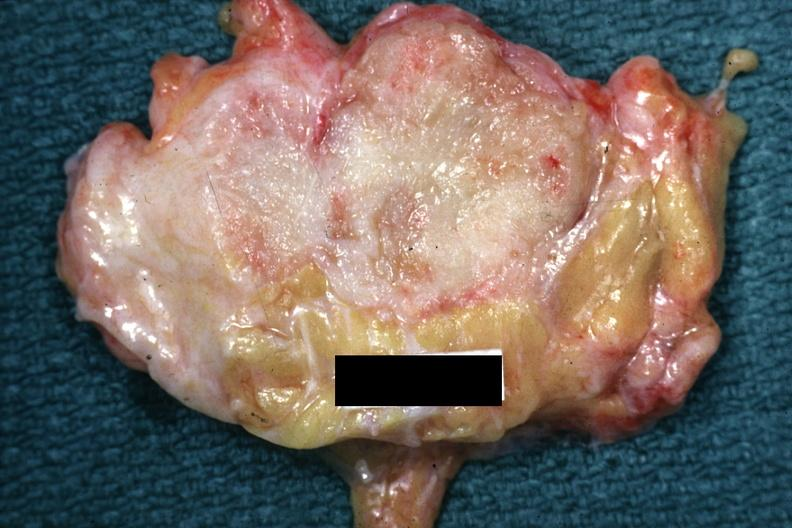s breast present?
Answer the question using a single word or phrase. Yes 